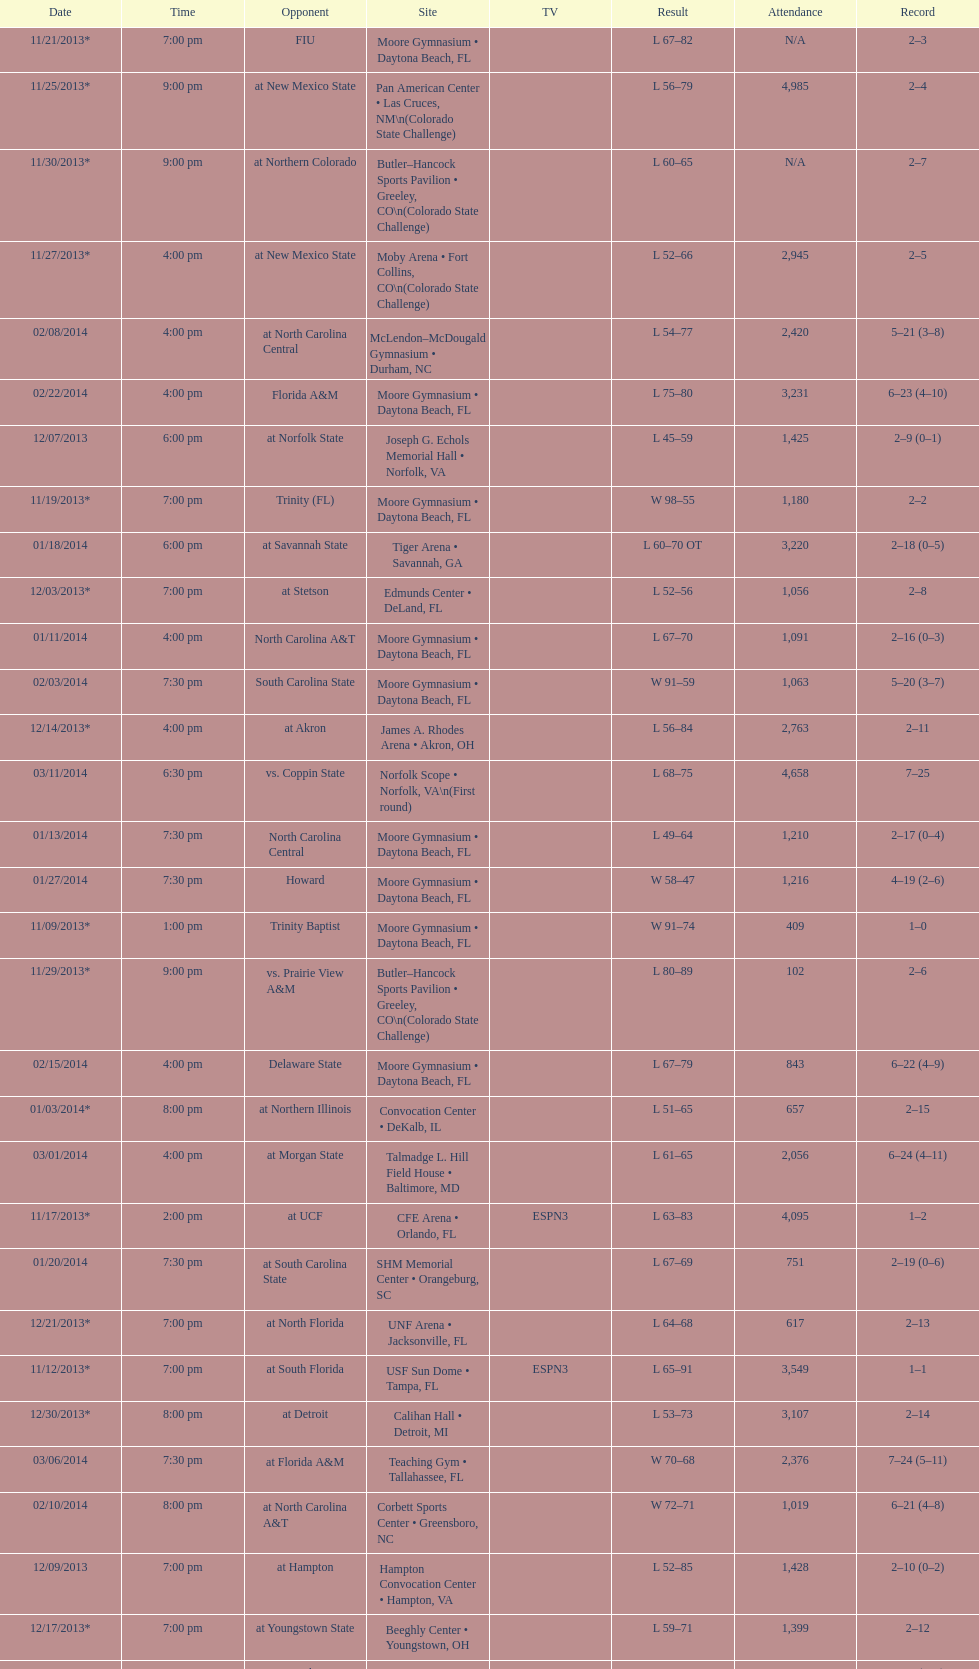How much larger was the attendance on 11/25/2013 than 12/21/2013? 4368. 